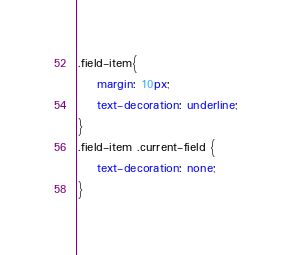Convert code to text. <code><loc_0><loc_0><loc_500><loc_500><_CSS_>.field-item{
    margin: 10px;
    text-decoration: underline;
}
.field-item .current-field {
    text-decoration: none;
}</code> 